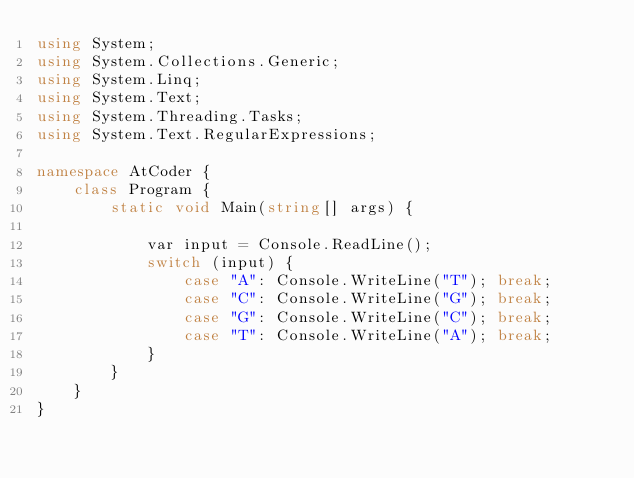<code> <loc_0><loc_0><loc_500><loc_500><_C#_>using System;
using System.Collections.Generic;
using System.Linq;
using System.Text;
using System.Threading.Tasks;
using System.Text.RegularExpressions;

namespace AtCoder {
    class Program {
        static void Main(string[] args) {

            var input = Console.ReadLine();
            switch (input) {
                case "A": Console.WriteLine("T"); break;
                case "C": Console.WriteLine("G"); break;
                case "G": Console.WriteLine("C"); break;
                case "T": Console.WriteLine("A"); break;
            }
        }
    }
}</code> 